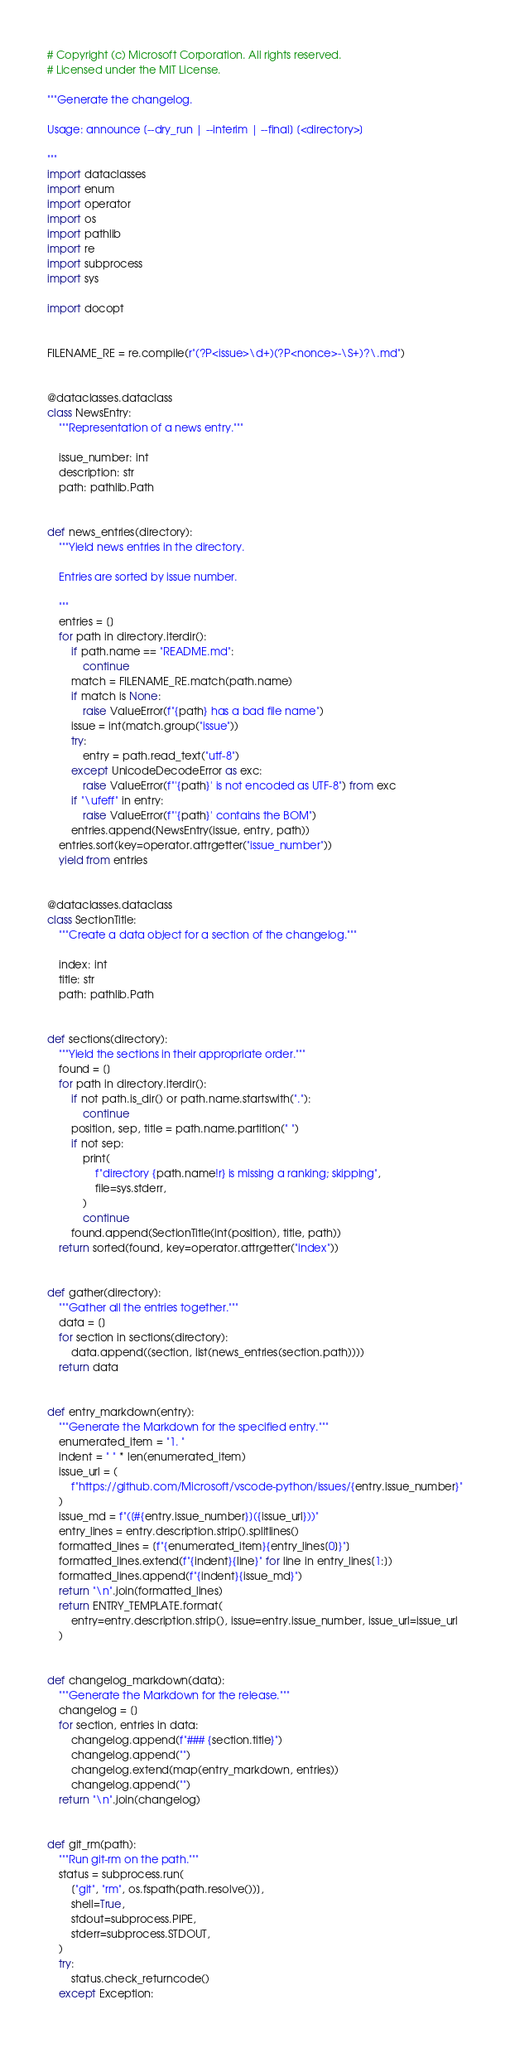Convert code to text. <code><loc_0><loc_0><loc_500><loc_500><_Python_># Copyright (c) Microsoft Corporation. All rights reserved.
# Licensed under the MIT License.

"""Generate the changelog.

Usage: announce [--dry_run | --interim | --final] [<directory>]

"""
import dataclasses
import enum
import operator
import os
import pathlib
import re
import subprocess
import sys

import docopt


FILENAME_RE = re.compile(r"(?P<issue>\d+)(?P<nonce>-\S+)?\.md")


@dataclasses.dataclass
class NewsEntry:
    """Representation of a news entry."""

    issue_number: int
    description: str
    path: pathlib.Path


def news_entries(directory):
    """Yield news entries in the directory.

    Entries are sorted by issue number.

    """
    entries = []
    for path in directory.iterdir():
        if path.name == "README.md":
            continue
        match = FILENAME_RE.match(path.name)
        if match is None:
            raise ValueError(f"{path} has a bad file name")
        issue = int(match.group("issue"))
        try:
            entry = path.read_text("utf-8")
        except UnicodeDecodeError as exc:
            raise ValueError(f"'{path}' is not encoded as UTF-8") from exc
        if "\ufeff" in entry:
            raise ValueError(f"'{path}' contains the BOM")
        entries.append(NewsEntry(issue, entry, path))
    entries.sort(key=operator.attrgetter("issue_number"))
    yield from entries


@dataclasses.dataclass
class SectionTitle:
    """Create a data object for a section of the changelog."""

    index: int
    title: str
    path: pathlib.Path


def sections(directory):
    """Yield the sections in their appropriate order."""
    found = []
    for path in directory.iterdir():
        if not path.is_dir() or path.name.startswith("."):
            continue
        position, sep, title = path.name.partition(" ")
        if not sep:
            print(
                f"directory {path.name!r} is missing a ranking; skipping",
                file=sys.stderr,
            )
            continue
        found.append(SectionTitle(int(position), title, path))
    return sorted(found, key=operator.attrgetter("index"))


def gather(directory):
    """Gather all the entries together."""
    data = []
    for section in sections(directory):
        data.append((section, list(news_entries(section.path))))
    return data


def entry_markdown(entry):
    """Generate the Markdown for the specified entry."""
    enumerated_item = "1. "
    indent = " " * len(enumerated_item)
    issue_url = (
        f"https://github.com/Microsoft/vscode-python/issues/{entry.issue_number}"
    )
    issue_md = f"([#{entry.issue_number}]({issue_url}))"
    entry_lines = entry.description.strip().splitlines()
    formatted_lines = [f"{enumerated_item}{entry_lines[0]}"]
    formatted_lines.extend(f"{indent}{line}" for line in entry_lines[1:])
    formatted_lines.append(f"{indent}{issue_md}")
    return "\n".join(formatted_lines)
    return ENTRY_TEMPLATE.format(
        entry=entry.description.strip(), issue=entry.issue_number, issue_url=issue_url
    )


def changelog_markdown(data):
    """Generate the Markdown for the release."""
    changelog = []
    for section, entries in data:
        changelog.append(f"### {section.title}")
        changelog.append("")
        changelog.extend(map(entry_markdown, entries))
        changelog.append("")
    return "\n".join(changelog)


def git_rm(path):
    """Run git-rm on the path."""
    status = subprocess.run(
        ["git", "rm", os.fspath(path.resolve())],
        shell=True,
        stdout=subprocess.PIPE,
        stderr=subprocess.STDOUT,
    )
    try:
        status.check_returncode()
    except Exception:</code> 